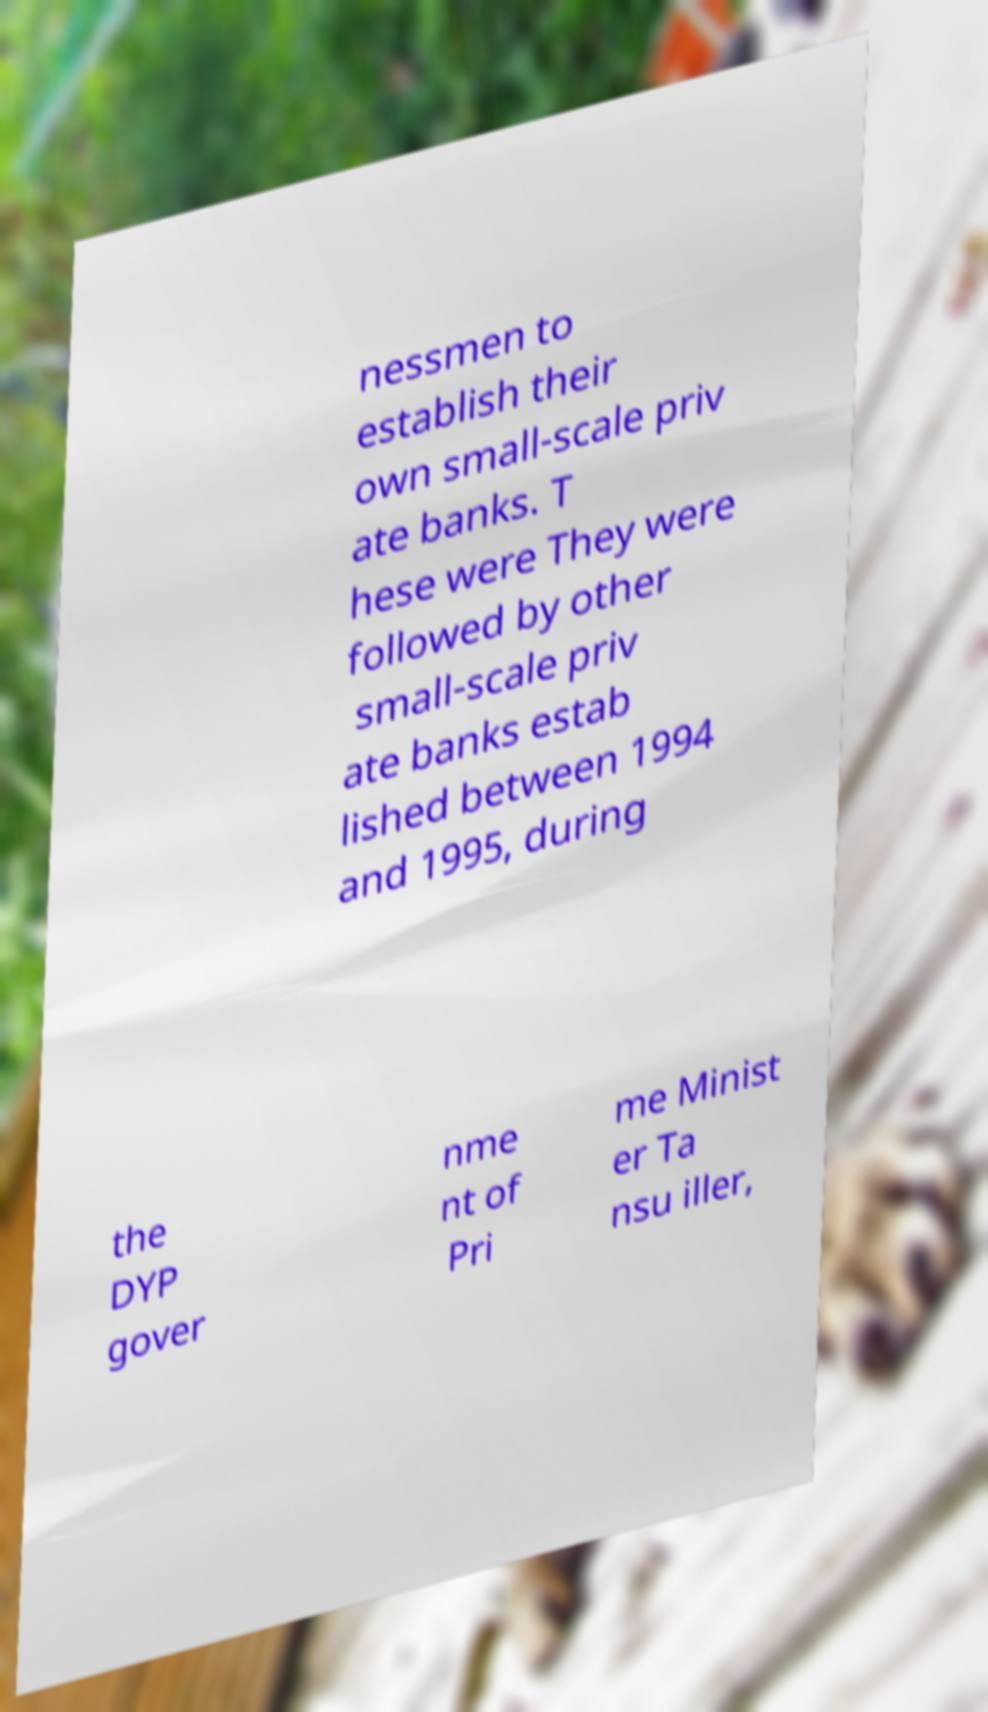Please identify and transcribe the text found in this image. nessmen to establish their own small-scale priv ate banks. T hese were They were followed by other small-scale priv ate banks estab lished between 1994 and 1995, during the DYP gover nme nt of Pri me Minist er Ta nsu iller, 